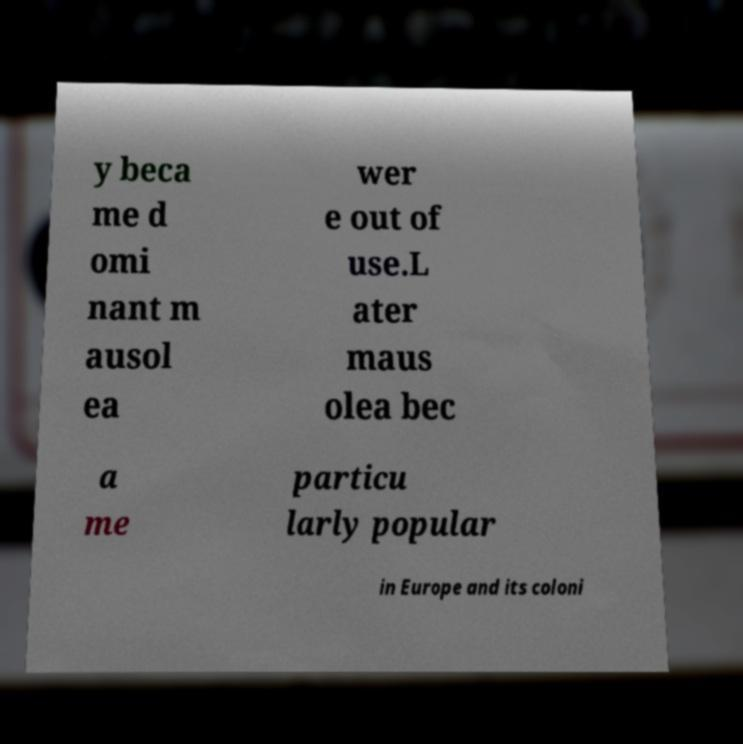For documentation purposes, I need the text within this image transcribed. Could you provide that? y beca me d omi nant m ausol ea wer e out of use.L ater maus olea bec a me particu larly popular in Europe and its coloni 